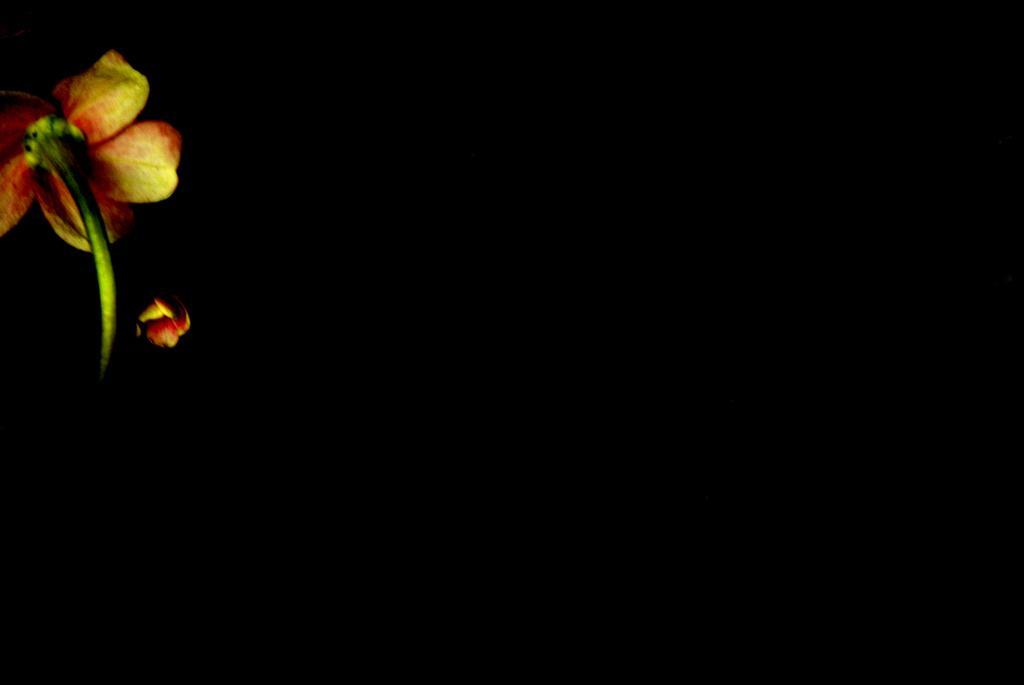In one or two sentences, can you explain what this image depicts? In this image there is a flower truncated towards the left of the image, the background of the image is dark. 